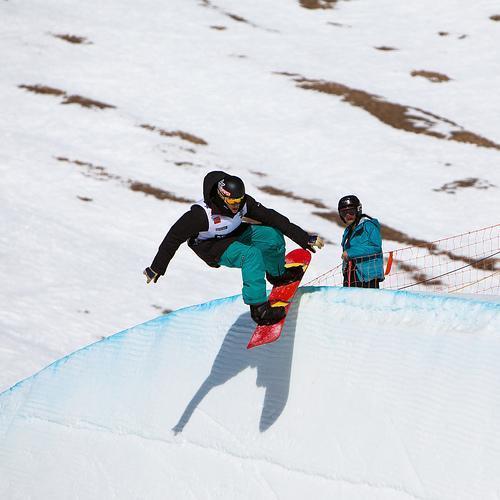How many snowboarders are there?
Give a very brief answer. 2. 